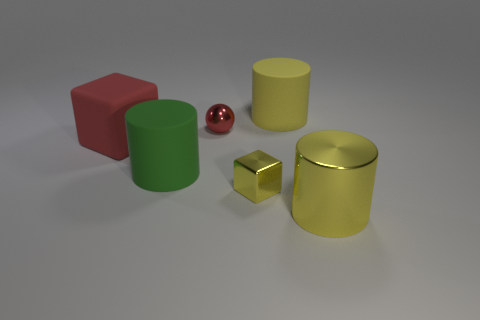What is the color of the thing that is both in front of the green matte thing and to the left of the yellow metal cylinder? There appears to be no item that is both in front of the green object and to the left of the yellow metal cylinder simultaneously. The objects to the left of the yellow cylinder and in front of the green object are distinct; the red cube is in front of the green cylinder and the small gold cube is to the left of the yellow cylinder. 